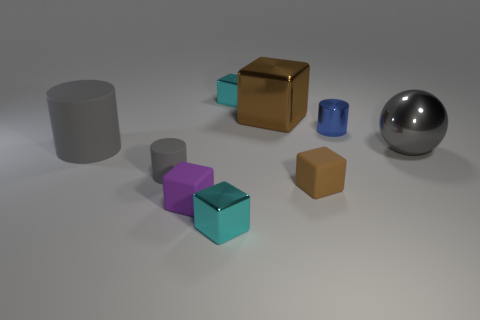Subtract all tiny metal blocks. How many blocks are left? 3 Subtract all yellow cylinders. How many brown cubes are left? 2 Subtract 1 cylinders. How many cylinders are left? 2 Subtract all blue cylinders. How many cylinders are left? 2 Subtract 0 green spheres. How many objects are left? 9 Subtract all cubes. How many objects are left? 4 Subtract all green cubes. Subtract all gray cylinders. How many cubes are left? 5 Subtract all purple blocks. Subtract all big brown metallic blocks. How many objects are left? 7 Add 1 cylinders. How many cylinders are left? 4 Add 6 rubber cylinders. How many rubber cylinders exist? 8 